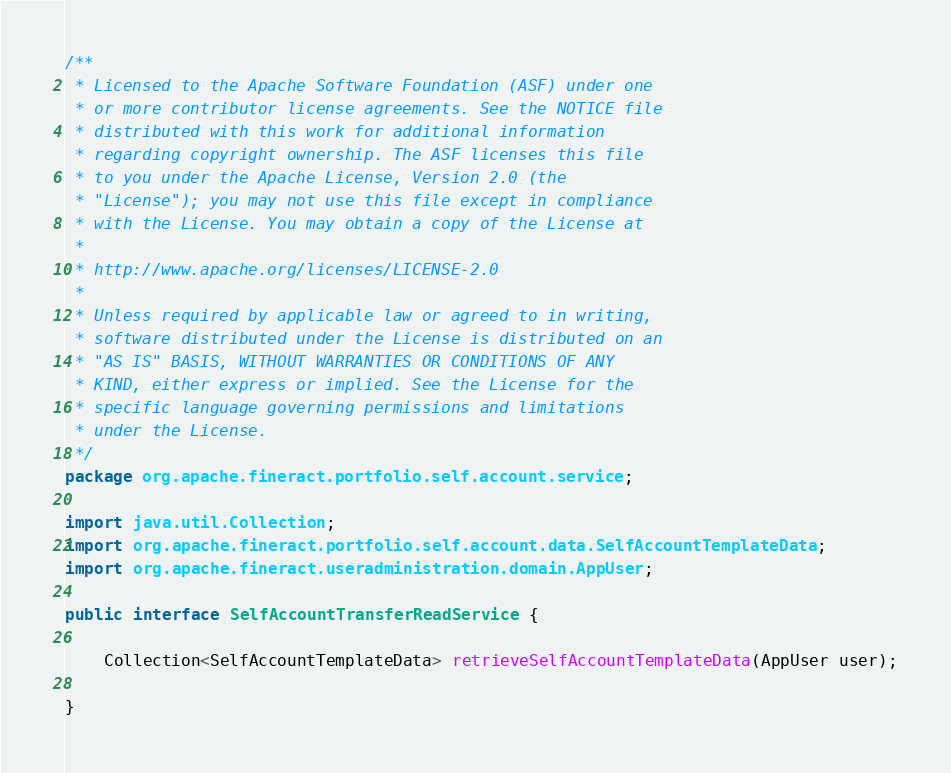<code> <loc_0><loc_0><loc_500><loc_500><_Java_>/**
 * Licensed to the Apache Software Foundation (ASF) under one
 * or more contributor license agreements. See the NOTICE file
 * distributed with this work for additional information
 * regarding copyright ownership. The ASF licenses this file
 * to you under the Apache License, Version 2.0 (the
 * "License"); you may not use this file except in compliance
 * with the License. You may obtain a copy of the License at
 *
 * http://www.apache.org/licenses/LICENSE-2.0
 *
 * Unless required by applicable law or agreed to in writing,
 * software distributed under the License is distributed on an
 * "AS IS" BASIS, WITHOUT WARRANTIES OR CONDITIONS OF ANY
 * KIND, either express or implied. See the License for the
 * specific language governing permissions and limitations
 * under the License.
 */
package org.apache.fineract.portfolio.self.account.service;

import java.util.Collection;
import org.apache.fineract.portfolio.self.account.data.SelfAccountTemplateData;
import org.apache.fineract.useradministration.domain.AppUser;

public interface SelfAccountTransferReadService {

    Collection<SelfAccountTemplateData> retrieveSelfAccountTemplateData(AppUser user);

}
</code> 